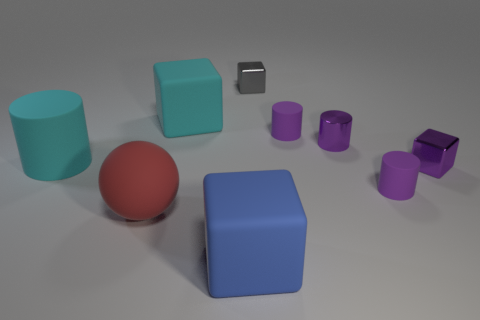There is a large block that is the same color as the large matte cylinder; what is its material?
Give a very brief answer. Rubber. There is a rubber block that is to the right of the rubber cube behind the big blue thing; what is its size?
Make the answer very short. Large. Is there a cyan cube made of the same material as the large red object?
Ensure brevity in your answer.  Yes. There is another cube that is the same size as the gray block; what is its material?
Your response must be concise. Metal. Do the block that is to the left of the large blue rubber cube and the large matte block in front of the metallic cylinder have the same color?
Keep it short and to the point. No. There is a big cube that is behind the large blue rubber block; is there a metal block that is on the left side of it?
Make the answer very short. No. Does the thing in front of the red rubber thing have the same shape as the cyan rubber object that is to the left of the rubber sphere?
Provide a succinct answer. No. Are the cylinder that is on the left side of the blue object and the small gray thing behind the big cylinder made of the same material?
Provide a succinct answer. No. What is the material of the cylinder that is left of the big matte block behind the big blue rubber object?
Your answer should be very brief. Rubber. The purple thing to the right of the small rubber thing in front of the small matte cylinder behind the metal cylinder is what shape?
Offer a terse response. Cube. 